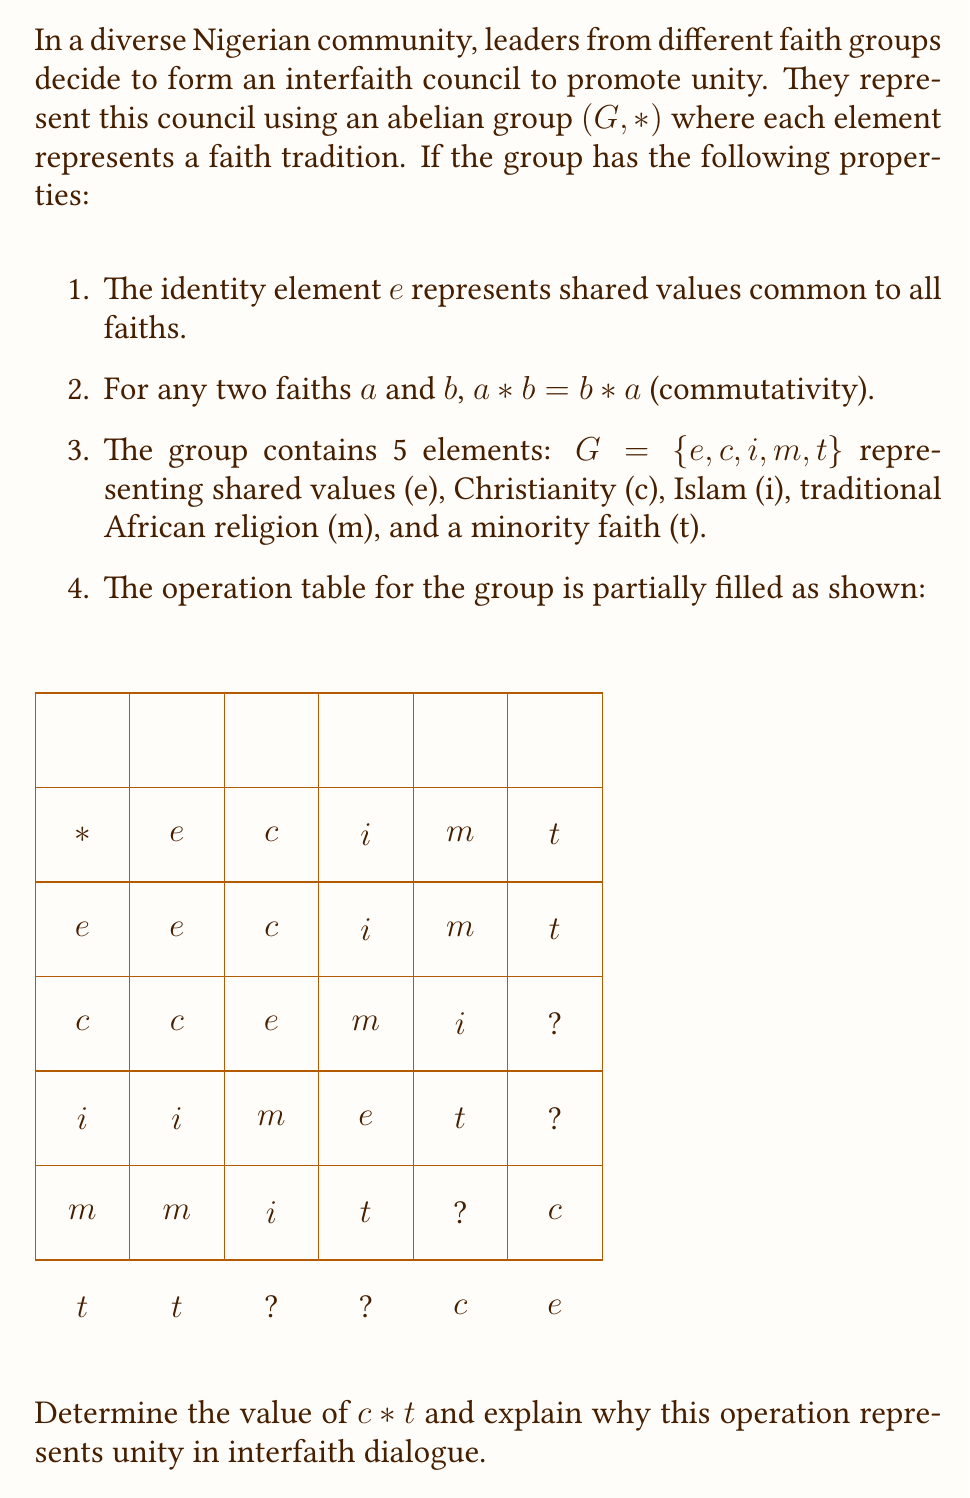Help me with this question. To solve this problem, we'll use the properties of abelian groups and the given information:

1) First, recall that in an abelian group, the operation is commutative. This means $c * t = t * c$.

2) Looking at the table, we see that $t * c$ is one of the missing values. However, we can determine it using other properties of groups.

3) In a group, each element must appear exactly once in each row and column. In the last row (for $t$), we're missing $i$ and $m$.

4) We can see that $c * t$ cannot be $i$ because $c * i = m$ (from the second row).

5) Therefore, $c * t = t * c = m$.

6) This operation represents unity in interfaith dialogue because:
   a) The commutative property ($c * t = t * c$) shows that the interaction between faiths is equal and reciprocal.
   b) The result $m$ (traditional African religion) demonstrates how interfaith dialogue can lead to a deeper appreciation of shared cultural roots.
   c) The fact that combining any two faiths results in another faith within the group illustrates how interfaith dialogue creates new understandings without losing individual identities.

7) The completed operation represents a "closed" system where all interactions lead to mutual understanding and respect, symbolized by staying within the group.
Answer: $c * t = m$ 